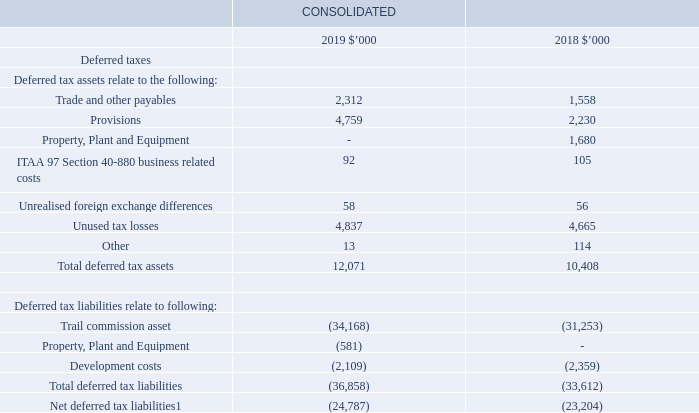2.6 Taxes (continued)
1 Net deferred tax liabilities include net deferred tax assets of $2,195,000 (2018: $1,937,000) from the iMoney Group.
Recognition and measurement
Our income tax expense is the sum of current and deferred income tax expenses. Current income tax expense is calculated on accounting profit after adjusting for non-taxable and non-deductible items based on rules set by the tax authorities. Deferred income tax expense is calculated at the tax rates that are expected to apply to the period in which the deferred tax asset is realised or the deferred tax liability is settled. Both our current and deferred income tax expenses are calculated using tax rates that have been enacted or substantively enacted at reporting date.
Our current and deferred taxes are recognised as an expense in profit or loss, except when they relate to items that are directly recognised in other comprehensive income or equity. In this case, our current and deferred tax expenses are also recognised directly in other comprehensive income or equity.
We generally recognise deferred tax liabilities for all taxable temporary differences, except to the extent that the deferred tax liability arises from:
• the initial recognition of goodwill; and
• the initial recognition of an asset or liability in a transaction that is not a business combination and affects neither our accounting profit nor our taxable income at the time of the transaction.
For our investments in controlled entities and associated entities, recognition of deferred tax liabilities is required unless we are able to control the timing of our temporary difference reversal and it is probable that the temporary difference will not reverse.
Deferred tax assets are recognised to the extent that it is probable that taxable profit will be available against which the deductible temporary differences, and the carried forward unused tax losses and tax credits, can be utilised
Deferred tax assets and deferred tax liabilities are offset in the statement of financial position where they relate to income taxes levied by the same taxation authority and to the extent that we intend to settle our current tax assets and liabilities on a net basis.
When is the recognition of deferred tax liabilities not required? We are able to control the timing of our temporary difference reversal and it is probable that the temporary difference will not reverse. What does the net deferred tax liabilities include? Net deferred tax assets of $2,195,000 (2018: $1,937,000) from the imoney group. What is the total deferred tax assets in 2019?
Answer scale should be: thousand. 12,071. In which year is there a higher total deferred tax assets? Find the year with the higher total deferred tax assets
Answer: 2019. In which year is the net deferred tax liabilities higher? Find the year with the higher net deferred tax liabilities
Answer: 2019. What is the percentage change in the net deferred tax liabilities from 2018 to 2019?
Answer scale should be: percent. (24,787-23,204)/23,204
Answer: 6.82. 